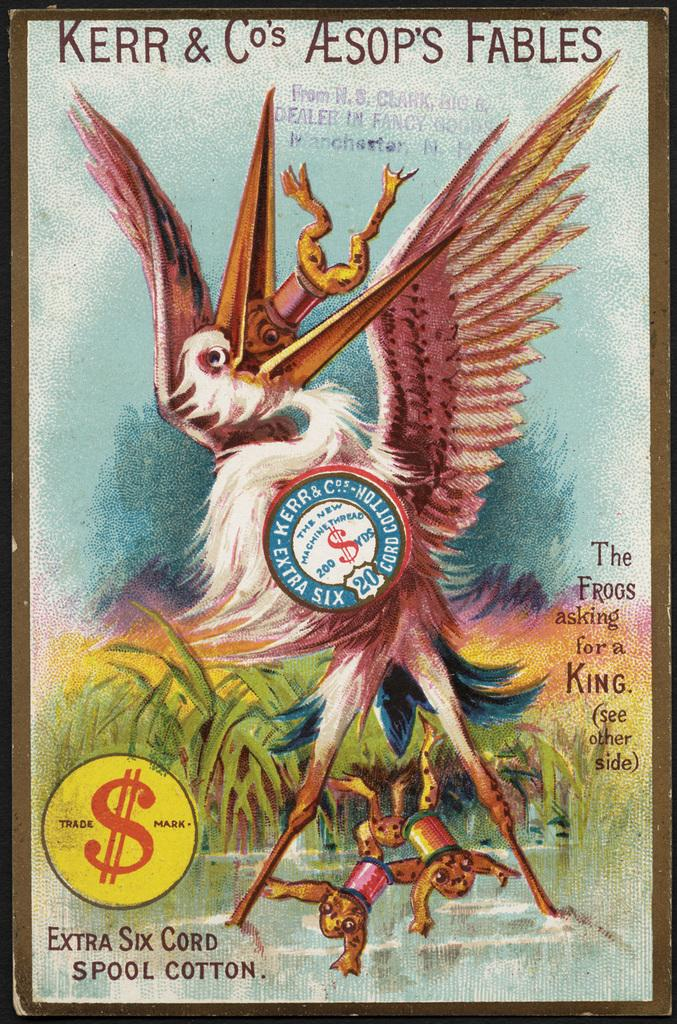<image>
Present a compact description of the photo's key features. A copy of Kerr & Co's Aesop's Fables from Manchester NH. 